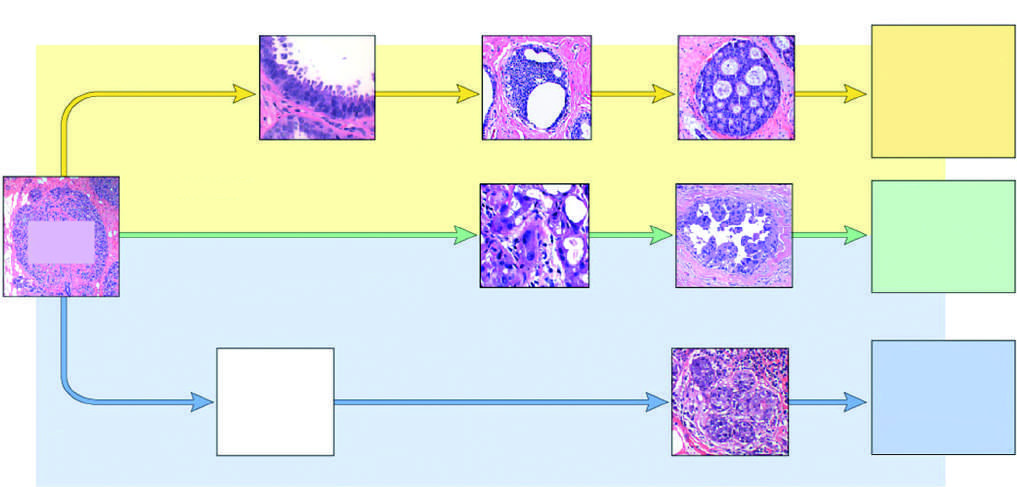does two helical spirochetes lead to er-positive cancers?
Answer the question using a single word or phrase. No 